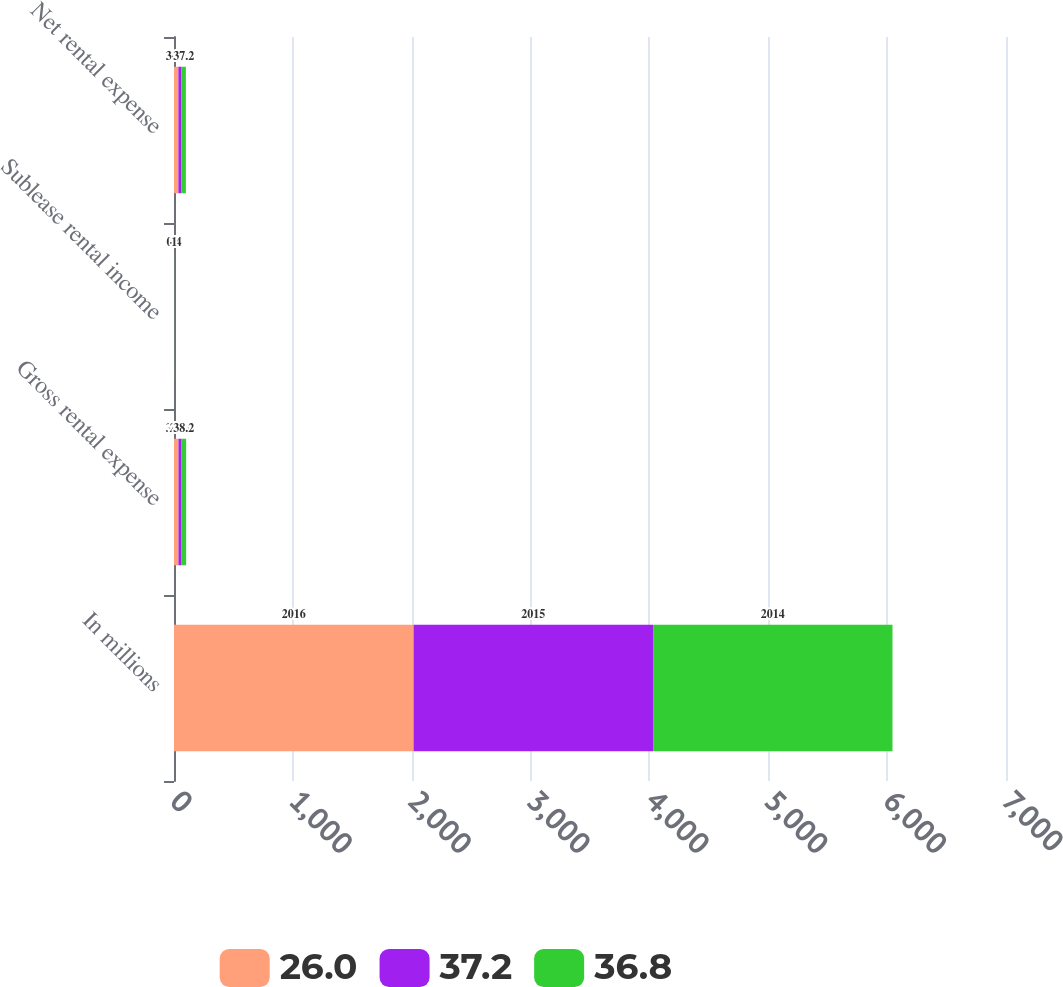Convert chart to OTSL. <chart><loc_0><loc_0><loc_500><loc_500><stacked_bar_chart><ecel><fcel>In millions<fcel>Gross rental expense<fcel>Sublease rental income<fcel>Net rental expense<nl><fcel>26<fcel>2016<fcel>37.5<fcel>0.7<fcel>36.8<nl><fcel>37.2<fcel>2015<fcel>26.4<fcel>0.4<fcel>26<nl><fcel>36.8<fcel>2014<fcel>38.2<fcel>1<fcel>37.2<nl></chart> 